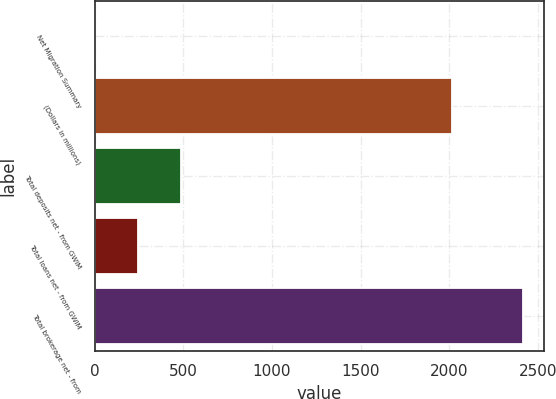<chart> <loc_0><loc_0><loc_500><loc_500><bar_chart><fcel>Net Migration Summary<fcel>(Dollars in millions)<fcel>Total deposits net - from GWIM<fcel>Total loans net - from GWIM<fcel>Total brokerage net - from<nl><fcel>1<fcel>2015<fcel>484<fcel>242.5<fcel>2416<nl></chart> 